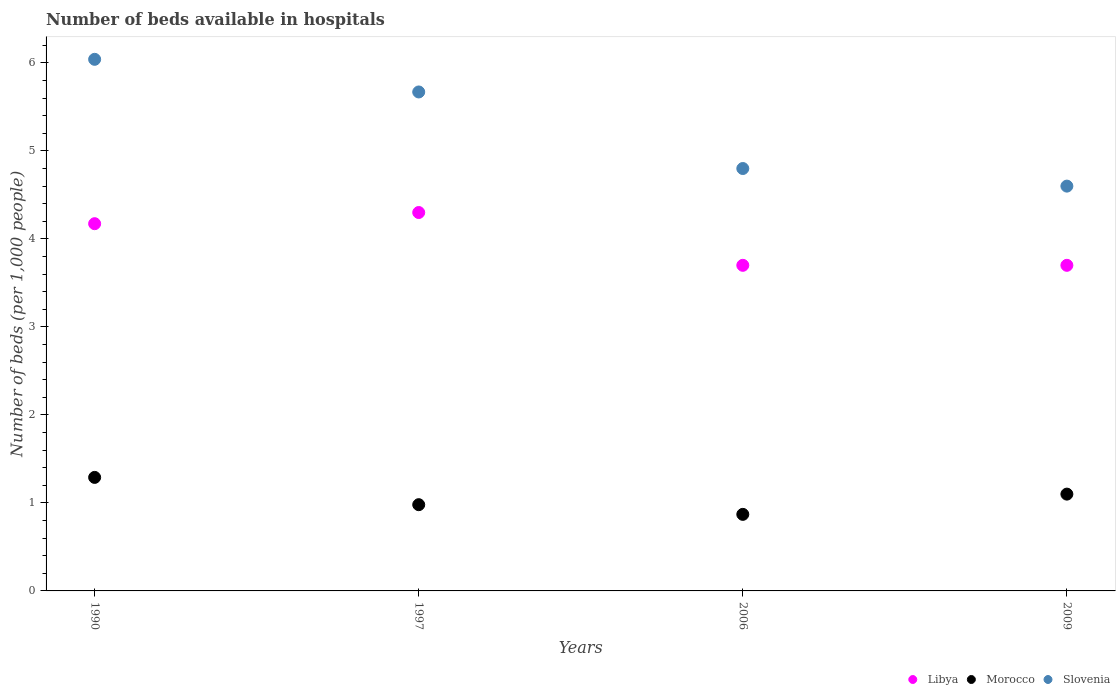What is the number of beds in the hospiatls of in Libya in 2009?
Ensure brevity in your answer.  3.7. Across all years, what is the maximum number of beds in the hospiatls of in Slovenia?
Ensure brevity in your answer.  6.04. In which year was the number of beds in the hospiatls of in Slovenia maximum?
Your answer should be compact. 1990. What is the total number of beds in the hospiatls of in Morocco in the graph?
Ensure brevity in your answer.  4.24. What is the difference between the number of beds in the hospiatls of in Slovenia in 1990 and that in 2006?
Keep it short and to the point. 1.24. What is the difference between the number of beds in the hospiatls of in Morocco in 1997 and the number of beds in the hospiatls of in Libya in 2009?
Ensure brevity in your answer.  -2.72. What is the average number of beds in the hospiatls of in Slovenia per year?
Ensure brevity in your answer.  5.28. In the year 2006, what is the difference between the number of beds in the hospiatls of in Morocco and number of beds in the hospiatls of in Libya?
Make the answer very short. -2.83. What is the ratio of the number of beds in the hospiatls of in Libya in 1990 to that in 2006?
Your response must be concise. 1.13. Is the difference between the number of beds in the hospiatls of in Morocco in 2006 and 2009 greater than the difference between the number of beds in the hospiatls of in Libya in 2006 and 2009?
Keep it short and to the point. No. What is the difference between the highest and the second highest number of beds in the hospiatls of in Morocco?
Ensure brevity in your answer.  0.19. What is the difference between the highest and the lowest number of beds in the hospiatls of in Morocco?
Your answer should be compact. 0.42. In how many years, is the number of beds in the hospiatls of in Morocco greater than the average number of beds in the hospiatls of in Morocco taken over all years?
Provide a short and direct response. 2. Is the sum of the number of beds in the hospiatls of in Libya in 1990 and 2006 greater than the maximum number of beds in the hospiatls of in Morocco across all years?
Offer a very short reply. Yes. Is it the case that in every year, the sum of the number of beds in the hospiatls of in Slovenia and number of beds in the hospiatls of in Morocco  is greater than the number of beds in the hospiatls of in Libya?
Make the answer very short. Yes. Does the number of beds in the hospiatls of in Libya monotonically increase over the years?
Ensure brevity in your answer.  No. How many years are there in the graph?
Provide a succinct answer. 4. What is the difference between two consecutive major ticks on the Y-axis?
Your answer should be very brief. 1. Are the values on the major ticks of Y-axis written in scientific E-notation?
Ensure brevity in your answer.  No. Does the graph contain any zero values?
Your answer should be very brief. No. Where does the legend appear in the graph?
Your answer should be compact. Bottom right. How are the legend labels stacked?
Your answer should be compact. Horizontal. What is the title of the graph?
Your answer should be very brief. Number of beds available in hospitals. What is the label or title of the Y-axis?
Your answer should be very brief. Number of beds (per 1,0 people). What is the Number of beds (per 1,000 people) in Libya in 1990?
Provide a succinct answer. 4.17. What is the Number of beds (per 1,000 people) in Morocco in 1990?
Provide a short and direct response. 1.29. What is the Number of beds (per 1,000 people) in Slovenia in 1990?
Give a very brief answer. 6.04. What is the Number of beds (per 1,000 people) of Libya in 1997?
Offer a terse response. 4.3. What is the Number of beds (per 1,000 people) of Morocco in 1997?
Give a very brief answer. 0.98. What is the Number of beds (per 1,000 people) of Slovenia in 1997?
Make the answer very short. 5.67. What is the Number of beds (per 1,000 people) of Libya in 2006?
Provide a succinct answer. 3.7. What is the Number of beds (per 1,000 people) in Morocco in 2006?
Your response must be concise. 0.87. What is the Number of beds (per 1,000 people) of Slovenia in 2006?
Provide a succinct answer. 4.8. What is the Number of beds (per 1,000 people) in Morocco in 2009?
Provide a short and direct response. 1.1. What is the Number of beds (per 1,000 people) of Slovenia in 2009?
Offer a very short reply. 4.6. Across all years, what is the maximum Number of beds (per 1,000 people) of Libya?
Offer a terse response. 4.3. Across all years, what is the maximum Number of beds (per 1,000 people) of Morocco?
Give a very brief answer. 1.29. Across all years, what is the maximum Number of beds (per 1,000 people) in Slovenia?
Give a very brief answer. 6.04. Across all years, what is the minimum Number of beds (per 1,000 people) in Morocco?
Keep it short and to the point. 0.87. What is the total Number of beds (per 1,000 people) in Libya in the graph?
Keep it short and to the point. 15.87. What is the total Number of beds (per 1,000 people) in Morocco in the graph?
Your answer should be very brief. 4.24. What is the total Number of beds (per 1,000 people) of Slovenia in the graph?
Your answer should be compact. 21.11. What is the difference between the Number of beds (per 1,000 people) in Libya in 1990 and that in 1997?
Provide a short and direct response. -0.13. What is the difference between the Number of beds (per 1,000 people) in Morocco in 1990 and that in 1997?
Offer a very short reply. 0.31. What is the difference between the Number of beds (per 1,000 people) in Slovenia in 1990 and that in 1997?
Your response must be concise. 0.37. What is the difference between the Number of beds (per 1,000 people) in Libya in 1990 and that in 2006?
Provide a short and direct response. 0.47. What is the difference between the Number of beds (per 1,000 people) of Morocco in 1990 and that in 2006?
Make the answer very short. 0.42. What is the difference between the Number of beds (per 1,000 people) of Slovenia in 1990 and that in 2006?
Offer a terse response. 1.24. What is the difference between the Number of beds (per 1,000 people) in Libya in 1990 and that in 2009?
Make the answer very short. 0.47. What is the difference between the Number of beds (per 1,000 people) in Morocco in 1990 and that in 2009?
Ensure brevity in your answer.  0.19. What is the difference between the Number of beds (per 1,000 people) in Slovenia in 1990 and that in 2009?
Your answer should be compact. 1.44. What is the difference between the Number of beds (per 1,000 people) of Morocco in 1997 and that in 2006?
Offer a terse response. 0.11. What is the difference between the Number of beds (per 1,000 people) in Slovenia in 1997 and that in 2006?
Provide a succinct answer. 0.87. What is the difference between the Number of beds (per 1,000 people) in Morocco in 1997 and that in 2009?
Make the answer very short. -0.12. What is the difference between the Number of beds (per 1,000 people) in Slovenia in 1997 and that in 2009?
Give a very brief answer. 1.07. What is the difference between the Number of beds (per 1,000 people) in Morocco in 2006 and that in 2009?
Make the answer very short. -0.23. What is the difference between the Number of beds (per 1,000 people) in Slovenia in 2006 and that in 2009?
Your response must be concise. 0.2. What is the difference between the Number of beds (per 1,000 people) of Libya in 1990 and the Number of beds (per 1,000 people) of Morocco in 1997?
Give a very brief answer. 3.19. What is the difference between the Number of beds (per 1,000 people) in Libya in 1990 and the Number of beds (per 1,000 people) in Slovenia in 1997?
Your response must be concise. -1.5. What is the difference between the Number of beds (per 1,000 people) of Morocco in 1990 and the Number of beds (per 1,000 people) of Slovenia in 1997?
Offer a terse response. -4.38. What is the difference between the Number of beds (per 1,000 people) in Libya in 1990 and the Number of beds (per 1,000 people) in Morocco in 2006?
Offer a terse response. 3.3. What is the difference between the Number of beds (per 1,000 people) of Libya in 1990 and the Number of beds (per 1,000 people) of Slovenia in 2006?
Keep it short and to the point. -0.63. What is the difference between the Number of beds (per 1,000 people) in Morocco in 1990 and the Number of beds (per 1,000 people) in Slovenia in 2006?
Ensure brevity in your answer.  -3.51. What is the difference between the Number of beds (per 1,000 people) in Libya in 1990 and the Number of beds (per 1,000 people) in Morocco in 2009?
Make the answer very short. 3.07. What is the difference between the Number of beds (per 1,000 people) in Libya in 1990 and the Number of beds (per 1,000 people) in Slovenia in 2009?
Ensure brevity in your answer.  -0.43. What is the difference between the Number of beds (per 1,000 people) in Morocco in 1990 and the Number of beds (per 1,000 people) in Slovenia in 2009?
Keep it short and to the point. -3.31. What is the difference between the Number of beds (per 1,000 people) in Libya in 1997 and the Number of beds (per 1,000 people) in Morocco in 2006?
Your answer should be compact. 3.43. What is the difference between the Number of beds (per 1,000 people) in Morocco in 1997 and the Number of beds (per 1,000 people) in Slovenia in 2006?
Provide a succinct answer. -3.82. What is the difference between the Number of beds (per 1,000 people) of Libya in 1997 and the Number of beds (per 1,000 people) of Slovenia in 2009?
Provide a succinct answer. -0.3. What is the difference between the Number of beds (per 1,000 people) of Morocco in 1997 and the Number of beds (per 1,000 people) of Slovenia in 2009?
Provide a short and direct response. -3.62. What is the difference between the Number of beds (per 1,000 people) of Libya in 2006 and the Number of beds (per 1,000 people) of Morocco in 2009?
Keep it short and to the point. 2.6. What is the difference between the Number of beds (per 1,000 people) in Libya in 2006 and the Number of beds (per 1,000 people) in Slovenia in 2009?
Provide a short and direct response. -0.9. What is the difference between the Number of beds (per 1,000 people) of Morocco in 2006 and the Number of beds (per 1,000 people) of Slovenia in 2009?
Ensure brevity in your answer.  -3.73. What is the average Number of beds (per 1,000 people) in Libya per year?
Keep it short and to the point. 3.97. What is the average Number of beds (per 1,000 people) of Morocco per year?
Your response must be concise. 1.06. What is the average Number of beds (per 1,000 people) in Slovenia per year?
Keep it short and to the point. 5.28. In the year 1990, what is the difference between the Number of beds (per 1,000 people) of Libya and Number of beds (per 1,000 people) of Morocco?
Make the answer very short. 2.88. In the year 1990, what is the difference between the Number of beds (per 1,000 people) in Libya and Number of beds (per 1,000 people) in Slovenia?
Offer a terse response. -1.87. In the year 1990, what is the difference between the Number of beds (per 1,000 people) in Morocco and Number of beds (per 1,000 people) in Slovenia?
Your response must be concise. -4.75. In the year 1997, what is the difference between the Number of beds (per 1,000 people) of Libya and Number of beds (per 1,000 people) of Morocco?
Your response must be concise. 3.32. In the year 1997, what is the difference between the Number of beds (per 1,000 people) of Libya and Number of beds (per 1,000 people) of Slovenia?
Your response must be concise. -1.37. In the year 1997, what is the difference between the Number of beds (per 1,000 people) in Morocco and Number of beds (per 1,000 people) in Slovenia?
Provide a succinct answer. -4.69. In the year 2006, what is the difference between the Number of beds (per 1,000 people) in Libya and Number of beds (per 1,000 people) in Morocco?
Keep it short and to the point. 2.83. In the year 2006, what is the difference between the Number of beds (per 1,000 people) in Morocco and Number of beds (per 1,000 people) in Slovenia?
Ensure brevity in your answer.  -3.93. In the year 2009, what is the difference between the Number of beds (per 1,000 people) of Libya and Number of beds (per 1,000 people) of Morocco?
Provide a short and direct response. 2.6. In the year 2009, what is the difference between the Number of beds (per 1,000 people) in Libya and Number of beds (per 1,000 people) in Slovenia?
Provide a succinct answer. -0.9. In the year 2009, what is the difference between the Number of beds (per 1,000 people) of Morocco and Number of beds (per 1,000 people) of Slovenia?
Keep it short and to the point. -3.5. What is the ratio of the Number of beds (per 1,000 people) of Libya in 1990 to that in 1997?
Offer a terse response. 0.97. What is the ratio of the Number of beds (per 1,000 people) in Morocco in 1990 to that in 1997?
Give a very brief answer. 1.32. What is the ratio of the Number of beds (per 1,000 people) of Slovenia in 1990 to that in 1997?
Offer a terse response. 1.07. What is the ratio of the Number of beds (per 1,000 people) in Libya in 1990 to that in 2006?
Give a very brief answer. 1.13. What is the ratio of the Number of beds (per 1,000 people) of Morocco in 1990 to that in 2006?
Offer a very short reply. 1.48. What is the ratio of the Number of beds (per 1,000 people) in Slovenia in 1990 to that in 2006?
Ensure brevity in your answer.  1.26. What is the ratio of the Number of beds (per 1,000 people) of Libya in 1990 to that in 2009?
Your answer should be compact. 1.13. What is the ratio of the Number of beds (per 1,000 people) of Morocco in 1990 to that in 2009?
Offer a very short reply. 1.17. What is the ratio of the Number of beds (per 1,000 people) of Slovenia in 1990 to that in 2009?
Provide a succinct answer. 1.31. What is the ratio of the Number of beds (per 1,000 people) of Libya in 1997 to that in 2006?
Give a very brief answer. 1.16. What is the ratio of the Number of beds (per 1,000 people) of Morocco in 1997 to that in 2006?
Give a very brief answer. 1.13. What is the ratio of the Number of beds (per 1,000 people) of Slovenia in 1997 to that in 2006?
Your answer should be compact. 1.18. What is the ratio of the Number of beds (per 1,000 people) in Libya in 1997 to that in 2009?
Provide a succinct answer. 1.16. What is the ratio of the Number of beds (per 1,000 people) of Morocco in 1997 to that in 2009?
Provide a succinct answer. 0.89. What is the ratio of the Number of beds (per 1,000 people) in Slovenia in 1997 to that in 2009?
Offer a terse response. 1.23. What is the ratio of the Number of beds (per 1,000 people) in Morocco in 2006 to that in 2009?
Provide a short and direct response. 0.79. What is the ratio of the Number of beds (per 1,000 people) in Slovenia in 2006 to that in 2009?
Your response must be concise. 1.04. What is the difference between the highest and the second highest Number of beds (per 1,000 people) of Libya?
Your response must be concise. 0.13. What is the difference between the highest and the second highest Number of beds (per 1,000 people) in Morocco?
Provide a succinct answer. 0.19. What is the difference between the highest and the second highest Number of beds (per 1,000 people) in Slovenia?
Offer a terse response. 0.37. What is the difference between the highest and the lowest Number of beds (per 1,000 people) of Morocco?
Your answer should be very brief. 0.42. What is the difference between the highest and the lowest Number of beds (per 1,000 people) in Slovenia?
Your response must be concise. 1.44. 